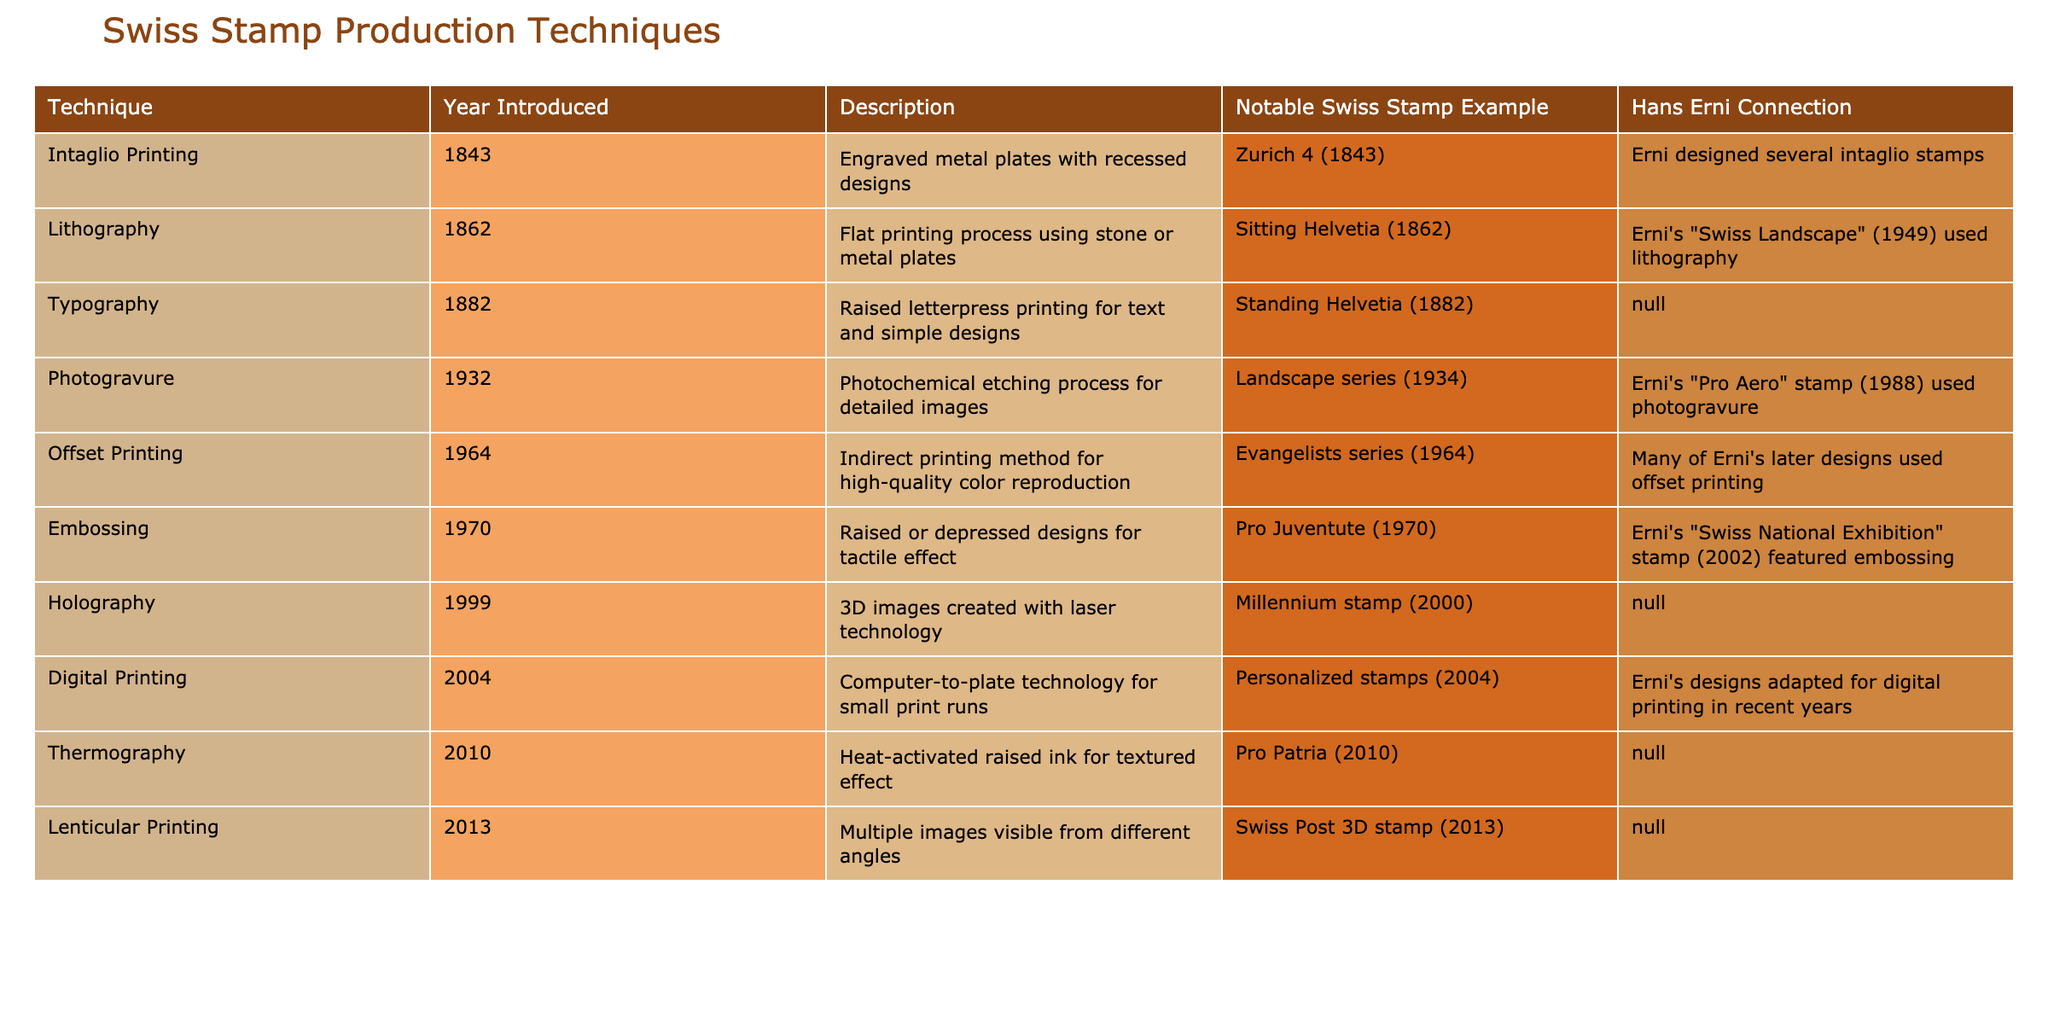What production technique was introduced in 1843? Looking at the table, the top entry shows that Intaglio Printing was introduced in 1843.
Answer: Intaglio Printing Which Swiss stamp example is connected to Hans Erni's intaglio designs? The notable Swiss stamp example associated with Erni's intaglio designs is the Zurich 4 (1843).
Answer: Zurich 4 (1843) How many techniques were introduced before 1970? By reviewing the years listed in the table, there are six techniques (Intaglio Printing, Lithography, Typography, Photogravure, Offset Printing, and Embossing) introduced before 1970.
Answer: 6 Is there a technique that uses embossing which is associated with Hans Erni? Checking the table, it confirms that the Pro Juventute (1970) stamp, which features embossing, has a connection to Hans Erni.
Answer: Yes What is the last production technique listed in the table? The table shows that Lenticular Printing, introduced in 2013, is the last production technique listed.
Answer: Lenticular Printing Which techniques have no connection to Hans Erni? Referring to the table, Typography, Holography, Thermography, and Lenticular Printing are techniques that do not have a connection to Hans Erni.
Answer: Typography, Holography, Thermography, Lenticular Printing How many techniques are specifically related to color reproduction? From the table, the techniques that relate specifically to color reproduction are Offset Printing and Lithography, bringing the total to two techniques.
Answer: 2 What was the median year of introduction for all techniques? The years of introduction are: 1843, 1862, 1882, 1932, 1964, 1970, 1999, 2004, 2010, and 2013. After sorting the years and finding the middle values 1964 and 1970, the median year is 1970.
Answer: 1970 